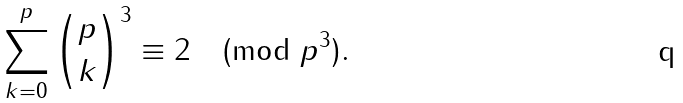<formula> <loc_0><loc_0><loc_500><loc_500>\sum _ { k = 0 } ^ { p } { p \choose k } ^ { 3 } \equiv 2 \pmod { p ^ { 3 } } .</formula> 